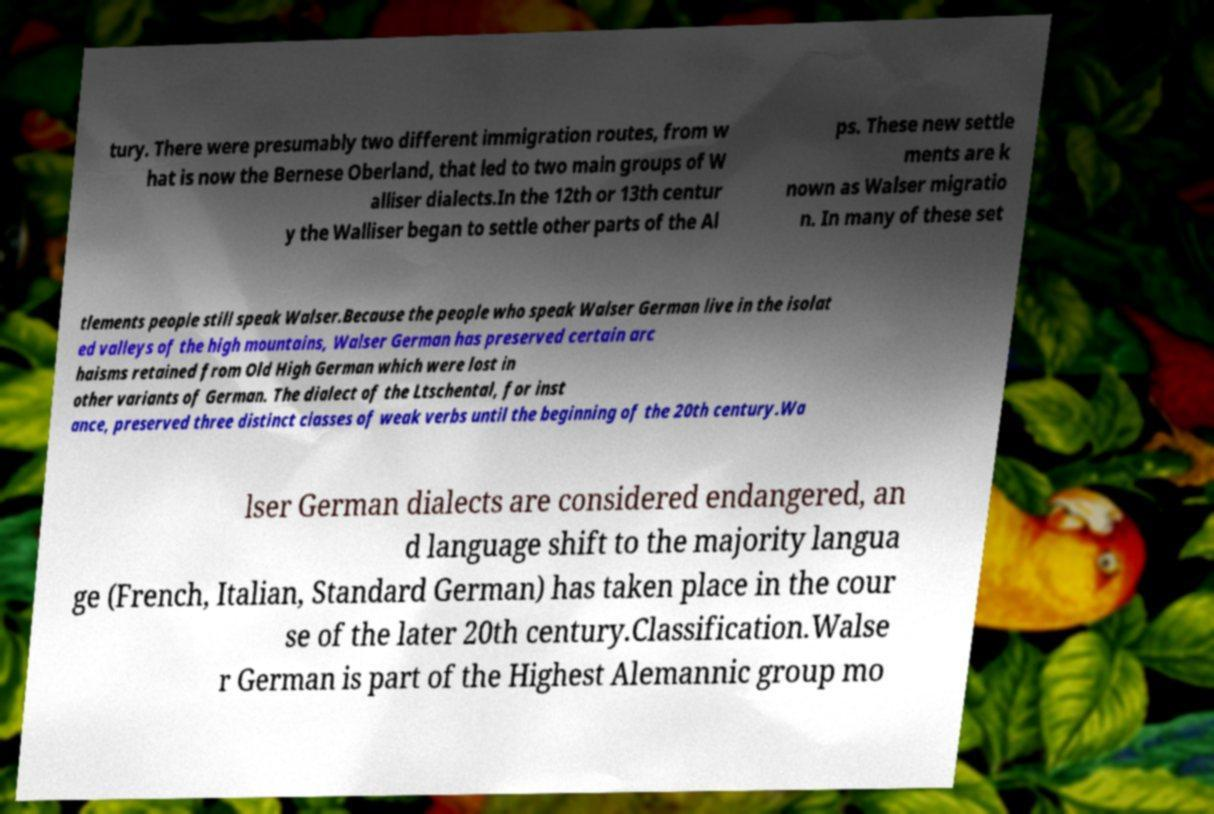What messages or text are displayed in this image? I need them in a readable, typed format. tury. There were presumably two different immigration routes, from w hat is now the Bernese Oberland, that led to two main groups of W alliser dialects.In the 12th or 13th centur y the Walliser began to settle other parts of the Al ps. These new settle ments are k nown as Walser migratio n. In many of these set tlements people still speak Walser.Because the people who speak Walser German live in the isolat ed valleys of the high mountains, Walser German has preserved certain arc haisms retained from Old High German which were lost in other variants of German. The dialect of the Ltschental, for inst ance, preserved three distinct classes of weak verbs until the beginning of the 20th century.Wa lser German dialects are considered endangered, an d language shift to the majority langua ge (French, Italian, Standard German) has taken place in the cour se of the later 20th century.Classification.Walse r German is part of the Highest Alemannic group mo 